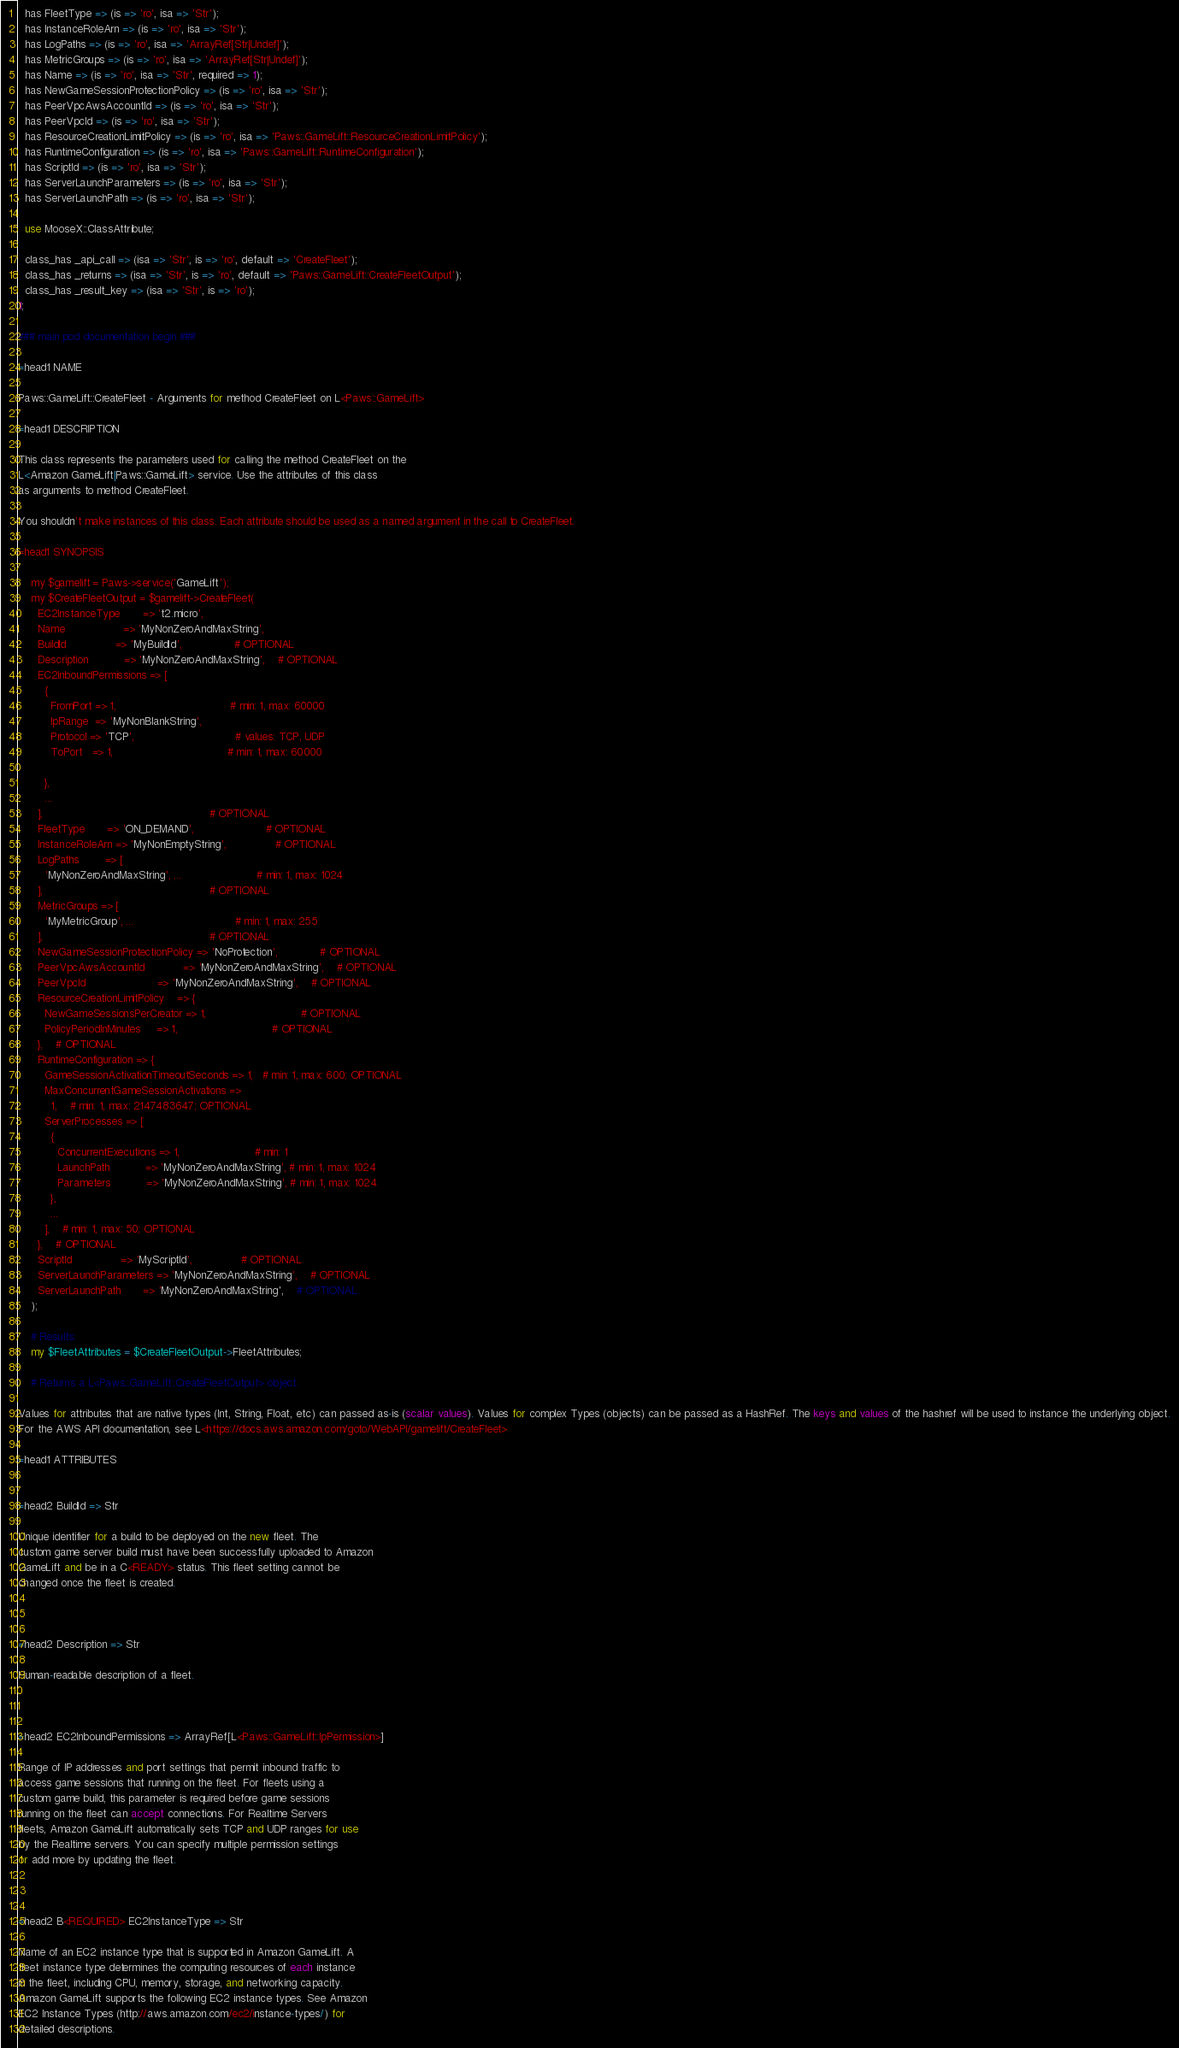Convert code to text. <code><loc_0><loc_0><loc_500><loc_500><_Perl_>  has FleetType => (is => 'ro', isa => 'Str');
  has InstanceRoleArn => (is => 'ro', isa => 'Str');
  has LogPaths => (is => 'ro', isa => 'ArrayRef[Str|Undef]');
  has MetricGroups => (is => 'ro', isa => 'ArrayRef[Str|Undef]');
  has Name => (is => 'ro', isa => 'Str', required => 1);
  has NewGameSessionProtectionPolicy => (is => 'ro', isa => 'Str');
  has PeerVpcAwsAccountId => (is => 'ro', isa => 'Str');
  has PeerVpcId => (is => 'ro', isa => 'Str');
  has ResourceCreationLimitPolicy => (is => 'ro', isa => 'Paws::GameLift::ResourceCreationLimitPolicy');
  has RuntimeConfiguration => (is => 'ro', isa => 'Paws::GameLift::RuntimeConfiguration');
  has ScriptId => (is => 'ro', isa => 'Str');
  has ServerLaunchParameters => (is => 'ro', isa => 'Str');
  has ServerLaunchPath => (is => 'ro', isa => 'Str');

  use MooseX::ClassAttribute;

  class_has _api_call => (isa => 'Str', is => 'ro', default => 'CreateFleet');
  class_has _returns => (isa => 'Str', is => 'ro', default => 'Paws::GameLift::CreateFleetOutput');
  class_has _result_key => (isa => 'Str', is => 'ro');
1;

### main pod documentation begin ###

=head1 NAME

Paws::GameLift::CreateFleet - Arguments for method CreateFleet on L<Paws::GameLift>

=head1 DESCRIPTION

This class represents the parameters used for calling the method CreateFleet on the
L<Amazon GameLift|Paws::GameLift> service. Use the attributes of this class
as arguments to method CreateFleet.

You shouldn't make instances of this class. Each attribute should be used as a named argument in the call to CreateFleet.

=head1 SYNOPSIS

    my $gamelift = Paws->service('GameLift');
    my $CreateFleetOutput = $gamelift->CreateFleet(
      EC2InstanceType       => 't2.micro',
      Name                  => 'MyNonZeroAndMaxString',
      BuildId               => 'MyBuildId',                # OPTIONAL
      Description           => 'MyNonZeroAndMaxString',    # OPTIONAL
      EC2InboundPermissions => [
        {
          FromPort => 1,                                   # min: 1, max: 60000
          IpRange  => 'MyNonBlankString',
          Protocol => 'TCP',                               # values: TCP, UDP
          ToPort   => 1,                                   # min: 1, max: 60000

        },
        ...
      ],                                                   # OPTIONAL
      FleetType       => 'ON_DEMAND',                      # OPTIONAL
      InstanceRoleArn => 'MyNonEmptyString',               # OPTIONAL
      LogPaths        => [
        'MyNonZeroAndMaxString', ...                       # min: 1, max: 1024
      ],                                                   # OPTIONAL
      MetricGroups => [
        'MyMetricGroup', ...                               # min: 1, max: 255
      ],                                                   # OPTIONAL
      NewGameSessionProtectionPolicy => 'NoProtection',             # OPTIONAL
      PeerVpcAwsAccountId            => 'MyNonZeroAndMaxString',    # OPTIONAL
      PeerVpcId                      => 'MyNonZeroAndMaxString',    # OPTIONAL
      ResourceCreationLimitPolicy    => {
        NewGameSessionsPerCreator => 1,                             # OPTIONAL
        PolicyPeriodInMinutes     => 1,                             # OPTIONAL
      },    # OPTIONAL
      RuntimeConfiguration => {
        GameSessionActivationTimeoutSeconds => 1,   # min: 1, max: 600; OPTIONAL
        MaxConcurrentGameSessionActivations =>
          1,    # min: 1, max: 2147483647; OPTIONAL
        ServerProcesses => [
          {
            ConcurrentExecutions => 1,                       # min: 1
            LaunchPath           => 'MyNonZeroAndMaxString', # min: 1, max: 1024
            Parameters           => 'MyNonZeroAndMaxString', # min: 1, max: 1024
          },
          ...
        ],    # min: 1, max: 50; OPTIONAL
      },    # OPTIONAL
      ScriptId               => 'MyScriptId',               # OPTIONAL
      ServerLaunchParameters => 'MyNonZeroAndMaxString',    # OPTIONAL
      ServerLaunchPath       => 'MyNonZeroAndMaxString',    # OPTIONAL
    );

    # Results:
    my $FleetAttributes = $CreateFleetOutput->FleetAttributes;

    # Returns a L<Paws::GameLift::CreateFleetOutput> object.

Values for attributes that are native types (Int, String, Float, etc) can passed as-is (scalar values). Values for complex Types (objects) can be passed as a HashRef. The keys and values of the hashref will be used to instance the underlying object.
For the AWS API documentation, see L<https://docs.aws.amazon.com/goto/WebAPI/gamelift/CreateFleet>

=head1 ATTRIBUTES


=head2 BuildId => Str

Unique identifier for a build to be deployed on the new fleet. The
custom game server build must have been successfully uploaded to Amazon
GameLift and be in a C<READY> status. This fleet setting cannot be
changed once the fleet is created.



=head2 Description => Str

Human-readable description of a fleet.



=head2 EC2InboundPermissions => ArrayRef[L<Paws::GameLift::IpPermission>]

Range of IP addresses and port settings that permit inbound traffic to
access game sessions that running on the fleet. For fleets using a
custom game build, this parameter is required before game sessions
running on the fleet can accept connections. For Realtime Servers
fleets, Amazon GameLift automatically sets TCP and UDP ranges for use
by the Realtime servers. You can specify multiple permission settings
or add more by updating the fleet.



=head2 B<REQUIRED> EC2InstanceType => Str

Name of an EC2 instance type that is supported in Amazon GameLift. A
fleet instance type determines the computing resources of each instance
in the fleet, including CPU, memory, storage, and networking capacity.
Amazon GameLift supports the following EC2 instance types. See Amazon
EC2 Instance Types (http://aws.amazon.com/ec2/instance-types/) for
detailed descriptions.
</code> 